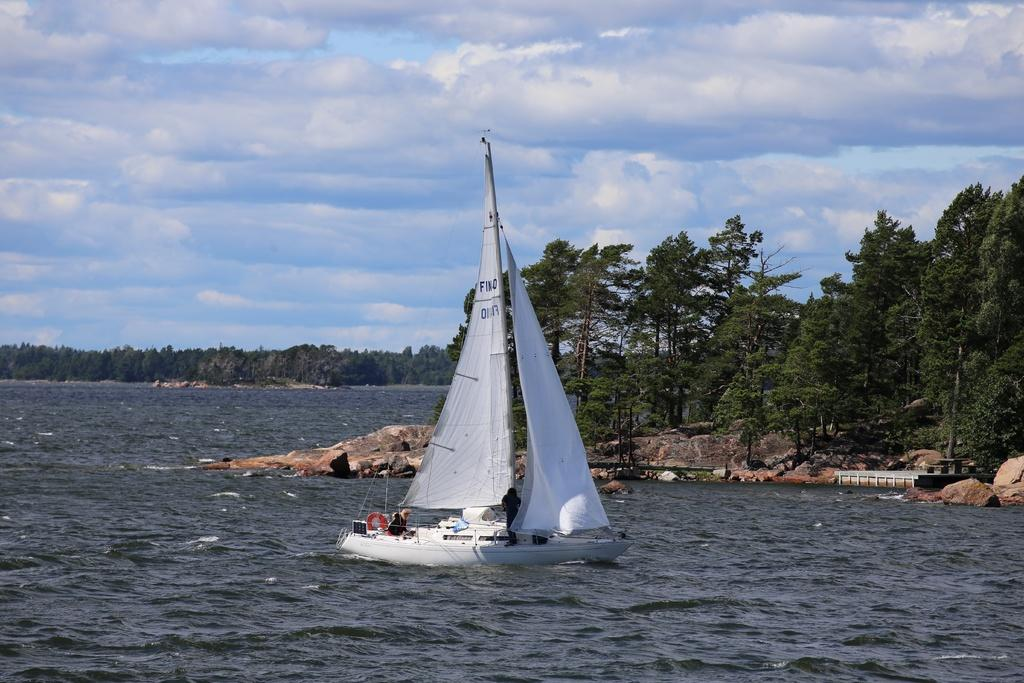What is the main subject of the image? The main subject of the image is a boat. Where is the boat located? The boat is on the water. What can be seen in the image besides the boat? There are trees visible in the image. What is visible in the background of the image? The sky is visible in the background of the image. What type of zipper can be seen on the boat in the image? There is no zipper present on the boat in the image. How many buttons are visible on the trees in the image? There are no buttons visible on the trees in the image. 